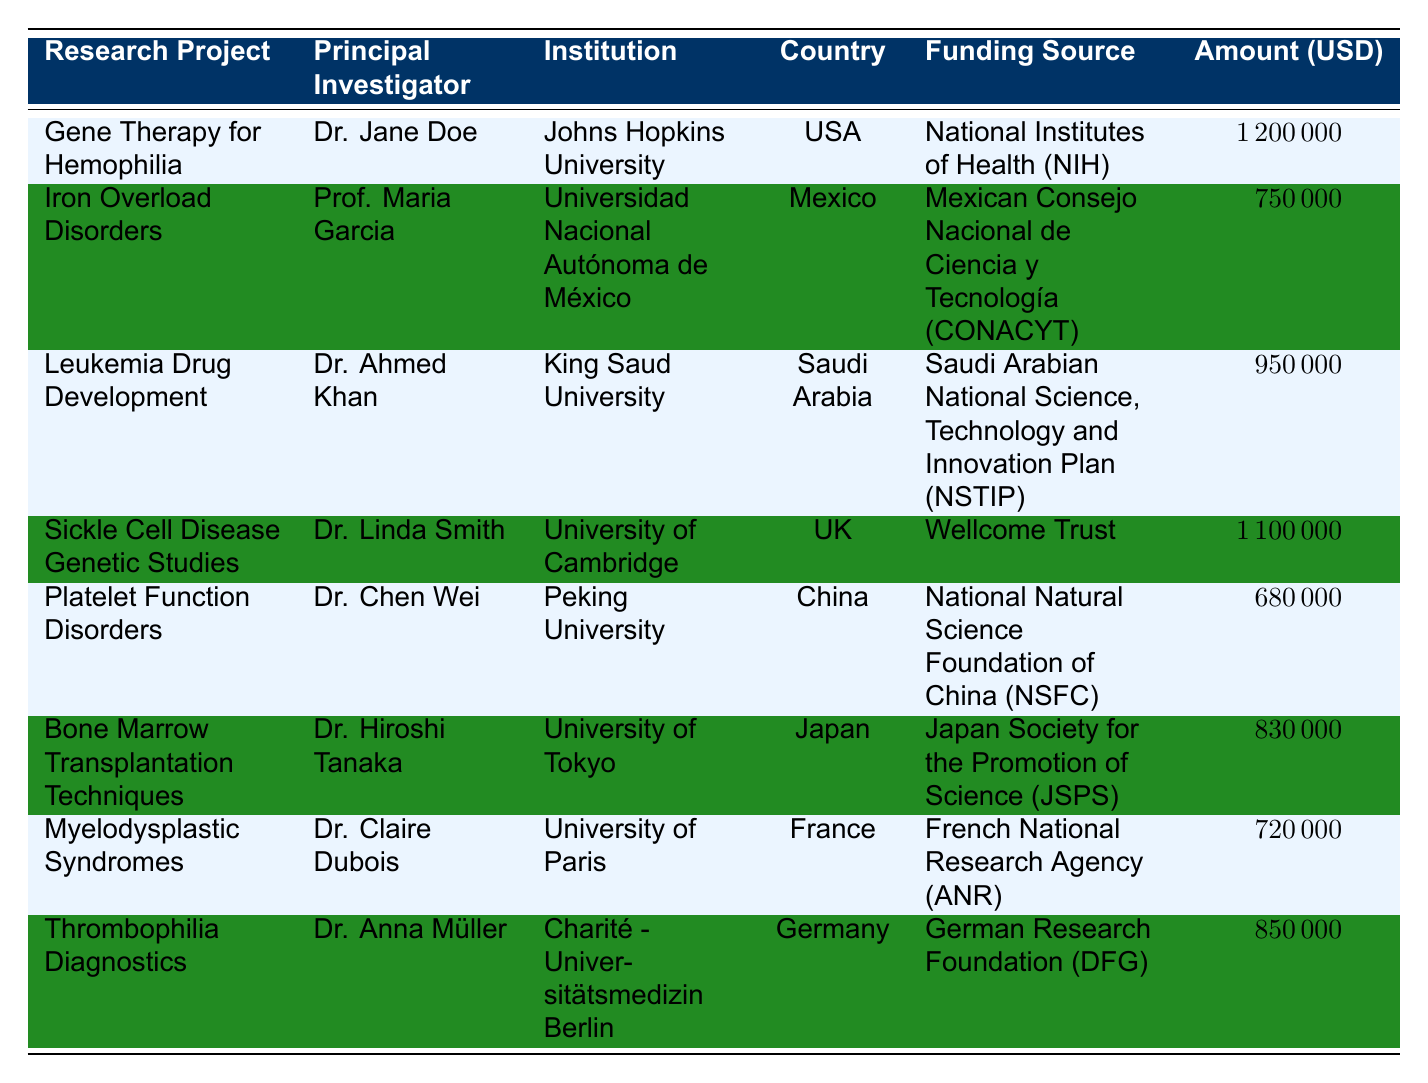What is the total amount awarded for research projects based in the USA? The table lists one project in the USA, the "Gene Therapy for Hemophilia," with an awarded amount of 1,200,000 USD. Since it is the only project from the USA, the total amount is simply the amount awarded to this project.
Answer: 1200000 USD Which research project received the lowest funding allocation? The project with the lowest funding allocation is "Platelet Function Disorders," which received 680,000 USD. This is identified by comparing all the funding amounts listed.
Answer: Platelet Function Disorders How many projects received funding from the Wellcome Trust? Only one project, "Sickle Cell Disease Genetic Studies," received funding from the Wellcome Trust. The table confirms this when we look for entries under the "Funding Source" column, and we find only one match.
Answer: 1 What is the total funding awarded for research projects in Japan and Germany combined? The total funding awarded for projects in Japan ("Bone Marrow Transplantation Techniques" - 830,000 USD) and Germany ("Thrombophilia Diagnostics" - 850,000 USD) needs to be summed. Adding these amounts together gives: 830,000 + 850,000 = 1,680,000 USD.
Answer: 1680000 USD Is the amount awarded for "Iron Overload Disorders" greater than the amount awarded for "Thrombophilia Diagnostics"? Comparing the two amounts, "Iron Overload Disorders" received 750,000 USD, while "Thrombophilia Diagnostics" received 850,000 USD. Since 750,000 is less than 850,000, the statement is false.
Answer: No What is the average funding amount awarded to research projects in the table? The total funding awarded is 1,200,000 + 750,000 + 950,000 + 1,100,000 + 680,000 + 830,000 + 720,000 + 850,000 = 6,080,000 USD. There are 8 projects listed, so the average is calculated by dividing the total funding by the number of projects: 6,080,000 / 8 = 760,000 USD.
Answer: 760000 USD Which country received the highest funding for their research project? The project with the highest funding is "Gene Therapy for Hemophilia," which is based in the USA and received 1,200,000 USD. To determine the country with the highest funding, I compared the amounts from all the projects and found that the USA holds the highest figure.
Answer: USA What is the funding source for the "Myelodysplastic Syndromes" research project? The funding source listed for the "Myelodysplastic Syndromes" project is the "French National Research Agency (ANR)." This can be identified by checking the "Funding Source" column corresponding to the project.
Answer: French National Research Agency (ANR) 